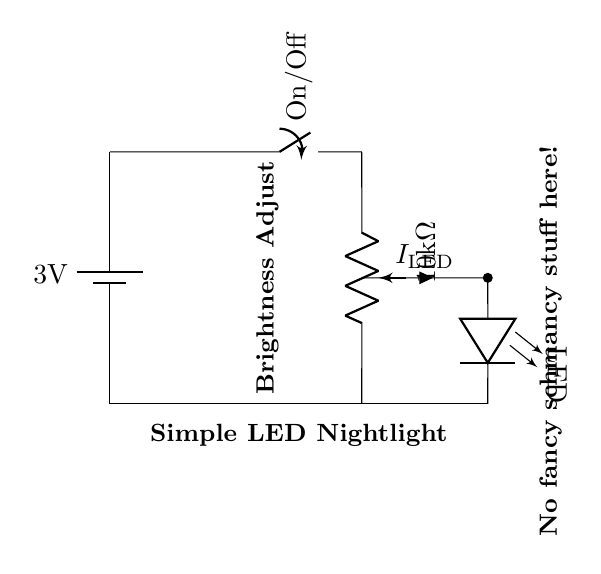What is the voltage of this circuit? The voltage of the circuit is 3 volts, as indicated by the battery labeled with the voltage value.
Answer: 3 volts What type of component is used to adjust brightness? The circuit includes a potentiometer, which is a variable resistor that allows for the adjustment of brightness by changing the resistance in the circuit.
Answer: Potentiometer What is the resistance value of the potentiometer? The potentiometer is labeled with a value of 10 kiloohms, meaning it has a maximum resistance of 10,000 ohms.
Answer: 10 kiloohms What is the indication of the switch in the circuit? The switch in the circuit allows for the control of power, indicating whether the nightlight can be turned on or off.
Answer: On/Off How does this circuit achieve adjustable brightness? The circuit achieves adjustable brightness through the use of the potentiometer, which varies the current flowing through the LED, allowing for different levels of brightness.
Answer: Varies current What component is responsible for producing light in the circuit? The LED is responsible for producing light, as it is designed to emit light when current flows through it.
Answer: LED What is the purpose of the ground connection in this circuit? The ground connection provides a common return path for the current in the circuit, completing the circuit for proper operation.
Answer: Common return path 